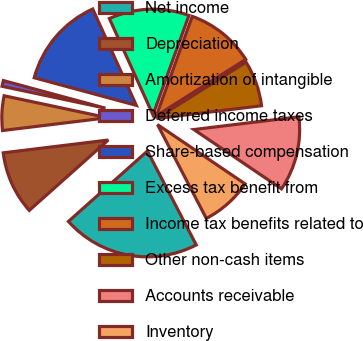Convert chart. <chart><loc_0><loc_0><loc_500><loc_500><pie_chart><fcel>Net income<fcel>Depreciation<fcel>Amortization of intangible<fcel>Deferred income taxes<fcel>Share-based compensation<fcel>Excess tax benefit from<fcel>Income tax benefits related to<fcel>Other non-cash items<fcel>Accounts receivable<fcel>Inventory<nl><fcel>21.05%<fcel>9.65%<fcel>5.26%<fcel>0.88%<fcel>14.03%<fcel>12.28%<fcel>10.53%<fcel>7.02%<fcel>11.4%<fcel>7.89%<nl></chart> 